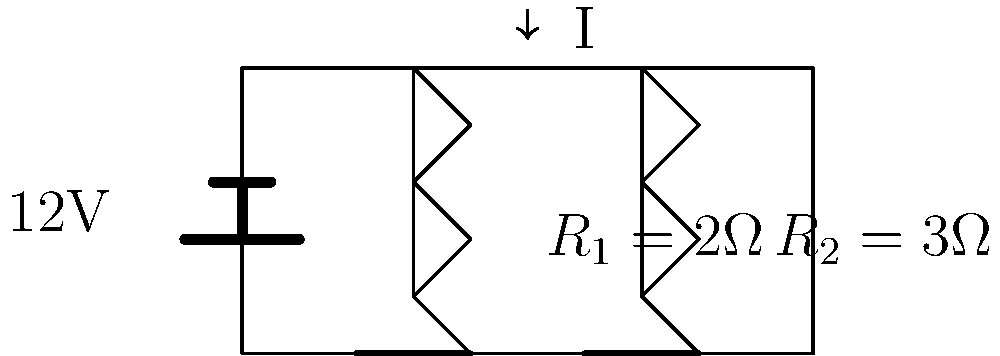In the series circuit shown, calculate the voltage drop across resistor $R_2$ if the total voltage source is 12V. Round your answer to one decimal place. To solve this problem, we'll follow these steps:

1) First, we need to calculate the total resistance in the circuit:
   $R_{total} = R_1 + R_2 = 2\Omega + 3\Omega = 5\Omega$

2) Now we can use Ohm's law to find the current in the circuit:
   $I = \frac{V}{R_{total}} = \frac{12V}{5\Omega} = 2.4A$

3) The voltage drop across each resistor is proportional to its resistance. We can use Ohm's law again to find the voltage drop across $R_2$:
   $V_{R2} = I \times R_2 = 2.4A \times 3\Omega = 7.2V$

4) Rounding to one decimal place:
   $V_{R2} \approx 7.2V$

This result makes sense because $R_2$ is 3/5 of the total resistance, so it should have 3/5 of the total voltage drop across it. Indeed, $7.2V$ is 3/5 of $12V$.
Answer: $7.2V$ 